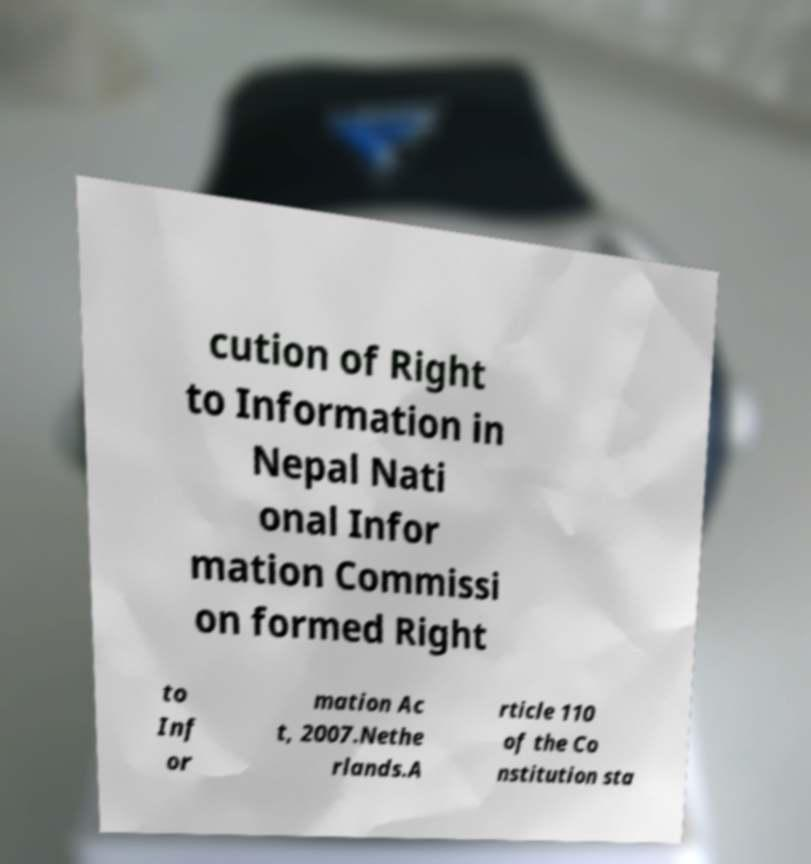I need the written content from this picture converted into text. Can you do that? cution of Right to Information in Nepal Nati onal Infor mation Commissi on formed Right to Inf or mation Ac t, 2007.Nethe rlands.A rticle 110 of the Co nstitution sta 